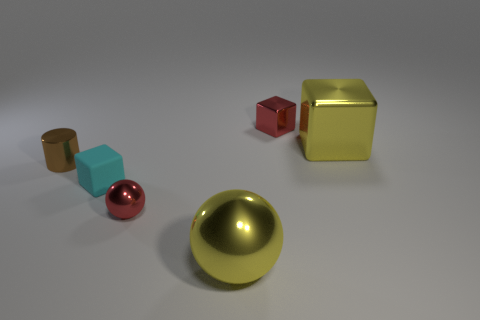What color is the big metallic thing that is the same shape as the tiny matte thing?
Ensure brevity in your answer.  Yellow. How many other small metal objects are the same shape as the cyan thing?
Ensure brevity in your answer.  1. There is a object that is the same color as the tiny ball; what is its material?
Keep it short and to the point. Metal. What number of big yellow metal things are there?
Make the answer very short. 2. Are there any brown things that have the same material as the tiny red ball?
Offer a very short reply. Yes. The object that is the same color as the large cube is what size?
Offer a very short reply. Large. There is a yellow thing in front of the brown metal object; is it the same size as the cube that is on the left side of the red block?
Give a very brief answer. No. There is a red sphere that is in front of the cyan thing; what is its size?
Provide a succinct answer. Small. Are there any other cylinders of the same color as the cylinder?
Provide a succinct answer. No. There is a big thing that is in front of the cylinder; is there a yellow metal sphere right of it?
Offer a very short reply. No. 